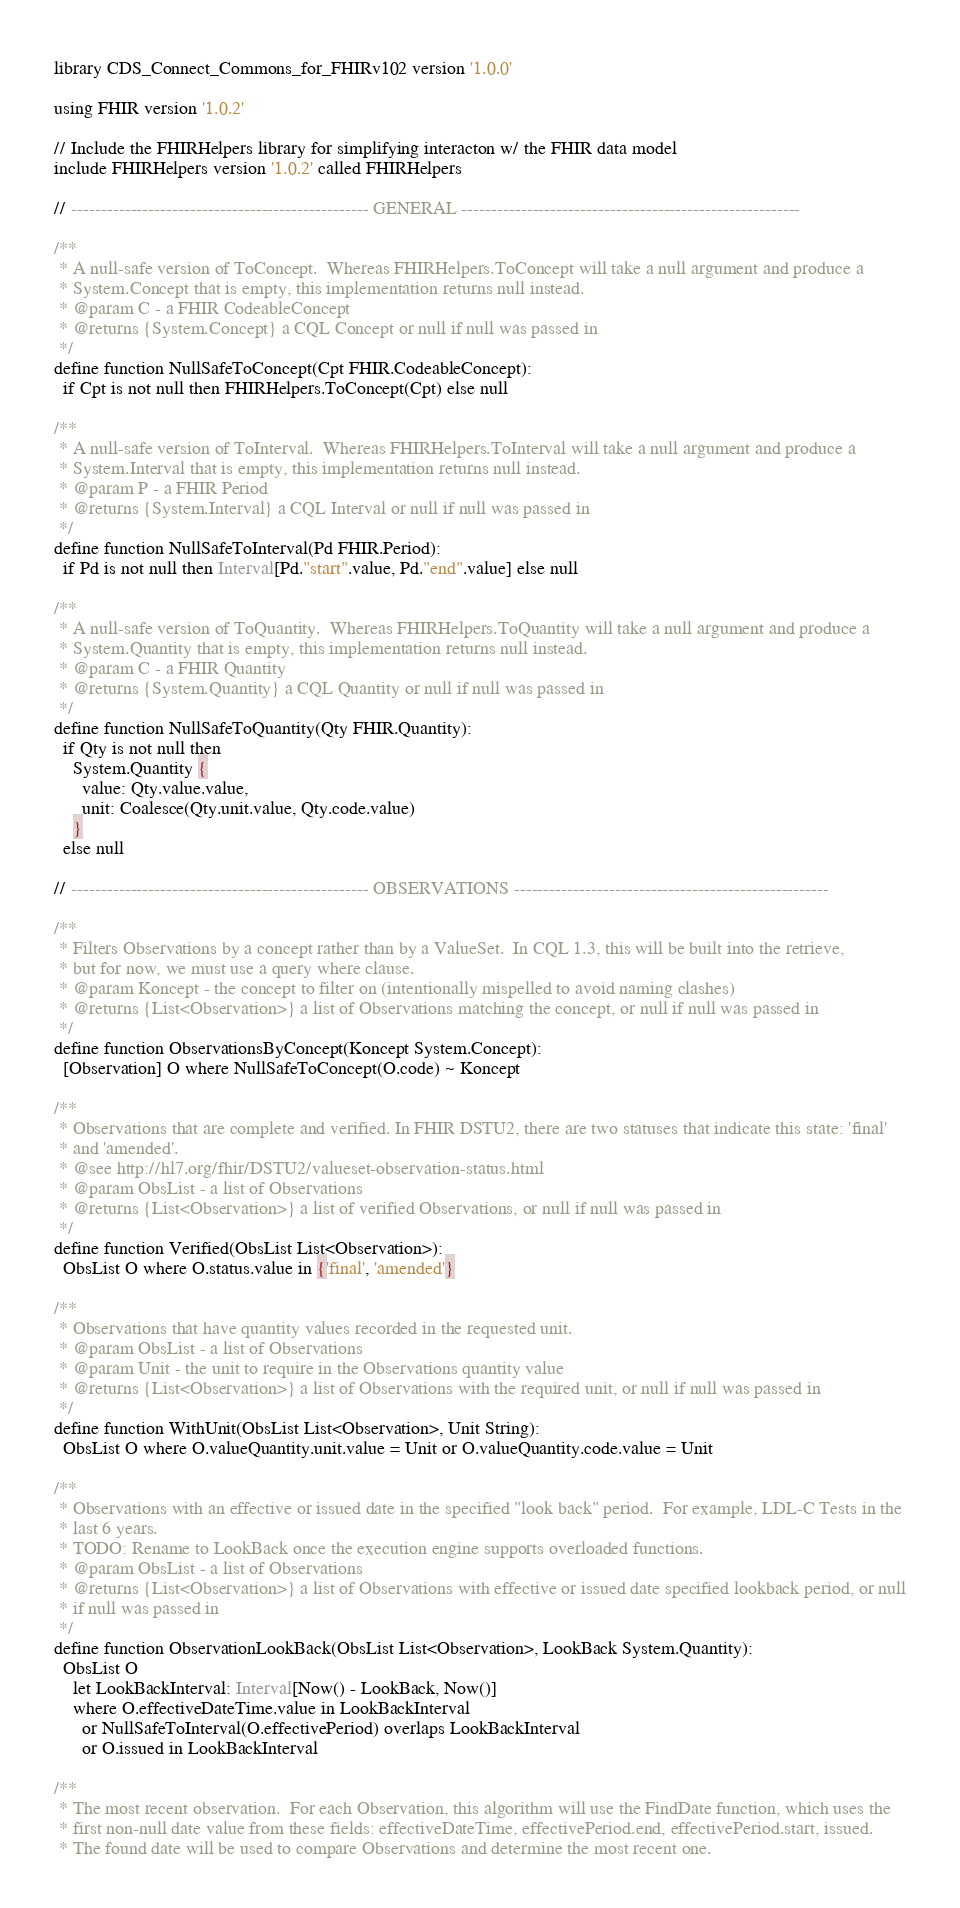<code> <loc_0><loc_0><loc_500><loc_500><_SQL_>library CDS_Connect_Commons_for_FHIRv102 version '1.0.0'

using FHIR version '1.0.2'

// Include the FHIRHelpers library for simplifying interacton w/ the FHIR data model
include FHIRHelpers version '1.0.2' called FHIRHelpers

// -------------------------------------------------- GENERAL ---------------------------------------------------------

/**
 * A null-safe version of ToConcept.  Whereas FHIRHelpers.ToConcept will take a null argument and produce a
 * System.Concept that is empty, this implementation returns null instead.
 * @param C - a FHIR CodeableConcept
 * @returns {System.Concept} a CQL Concept or null if null was passed in
 */
define function NullSafeToConcept(Cpt FHIR.CodeableConcept):
  if Cpt is not null then FHIRHelpers.ToConcept(Cpt) else null

/**
 * A null-safe version of ToInterval.  Whereas FHIRHelpers.ToInterval will take a null argument and produce a
 * System.Interval that is empty, this implementation returns null instead.
 * @param P - a FHIR Period
 * @returns {System.Interval} a CQL Interval or null if null was passed in
 */
define function NullSafeToInterval(Pd FHIR.Period):
  if Pd is not null then Interval[Pd."start".value, Pd."end".value] else null

/**
 * A null-safe version of ToQuantity.  Whereas FHIRHelpers.ToQuantity will take a null argument and produce a
 * System.Quantity that is empty, this implementation returns null instead.
 * @param C - a FHIR Quantity
 * @returns {System.Quantity} a CQL Quantity or null if null was passed in
 */
define function NullSafeToQuantity(Qty FHIR.Quantity):
  if Qty is not null then
    System.Quantity {
      value: Qty.value.value,
      unit: Coalesce(Qty.unit.value, Qty.code.value)
    }
  else null

// -------------------------------------------------- OBSERVATIONS -----------------------------------------------------

/**
 * Filters Observations by a concept rather than by a ValueSet.  In CQL 1.3, this will be built into the retrieve,
 * but for now, we must use a query where clause.
 * @param Koncept - the concept to filter on (intentionally mispelled to avoid naming clashes)
 * @returns {List<Observation>} a list of Observations matching the concept, or null if null was passed in
 */
define function ObservationsByConcept(Koncept System.Concept):
  [Observation] O where NullSafeToConcept(O.code) ~ Koncept

/**
 * Observations that are complete and verified. In FHIR DSTU2, there are two statuses that indicate this state: 'final'
 * and 'amended'.
 * @see http://hl7.org/fhir/DSTU2/valueset-observation-status.html
 * @param ObsList - a list of Observations
 * @returns {List<Observation>} a list of verified Observations, or null if null was passed in
 */
define function Verified(ObsList List<Observation>):
  ObsList O where O.status.value in {'final', 'amended'}

/**
 * Observations that have quantity values recorded in the requested unit.
 * @param ObsList - a list of Observations
 * @param Unit - the unit to require in the Observations quantity value
 * @returns {List<Observation>} a list of Observations with the required unit, or null if null was passed in
 */
define function WithUnit(ObsList List<Observation>, Unit String):
  ObsList O where O.valueQuantity.unit.value = Unit or O.valueQuantity.code.value = Unit

/**
 * Observations with an effective or issued date in the specified "look back" period.  For example, LDL-C Tests in the
 * last 6 years.
 * TODO: Rename to LookBack once the execution engine supports overloaded functions.
 * @param ObsList - a list of Observations
 * @returns {List<Observation>} a list of Observations with effective or issued date specified lookback period, or null
 * if null was passed in
 */
define function ObservationLookBack(ObsList List<Observation>, LookBack System.Quantity):
  ObsList O
    let LookBackInterval: Interval[Now() - LookBack, Now()]
    where O.effectiveDateTime.value in LookBackInterval
      or NullSafeToInterval(O.effectivePeriod) overlaps LookBackInterval
      or O.issued in LookBackInterval

/**
 * The most recent observation.  For each Observation, this algorithm will use the FindDate function, which uses the
 * first non-null date value from these fields: effectiveDateTime, effectivePeriod.end, effectivePeriod.start, issued.
 * The found date will be used to compare Observations and determine the most recent one.</code> 